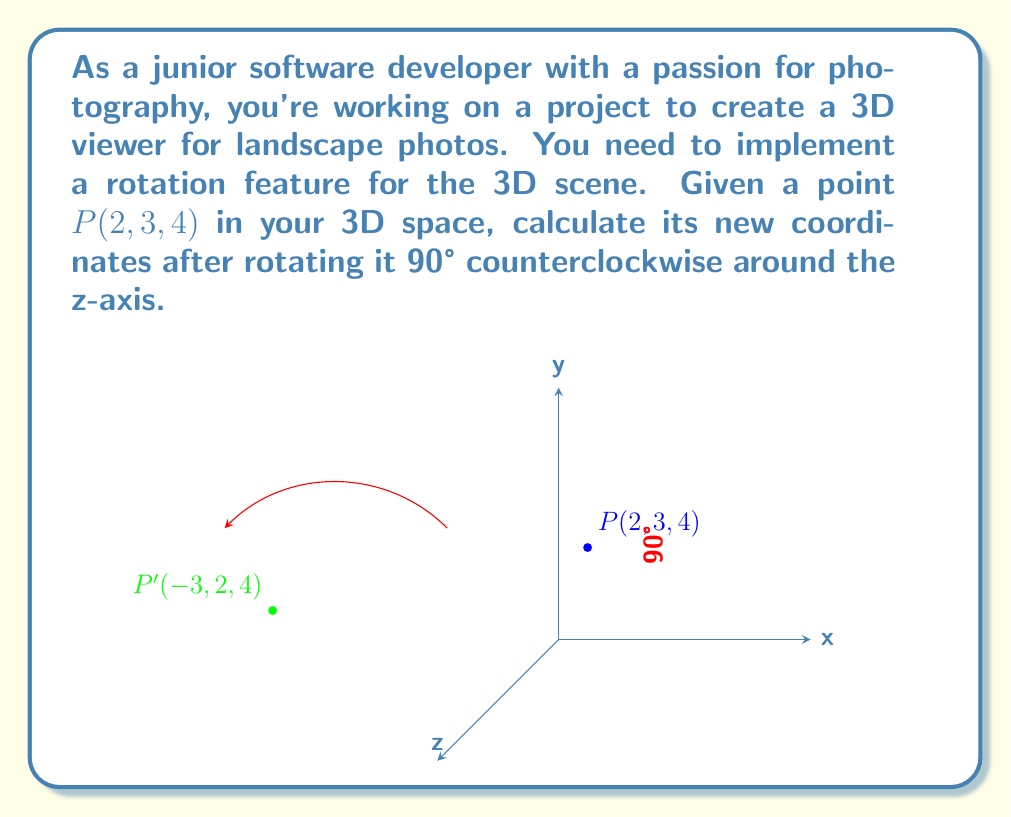Teach me how to tackle this problem. To solve this problem, we'll use the rotation matrix for a counterclockwise rotation around the z-axis:

$$R_z(\theta) = \begin{bmatrix}
\cos\theta & -\sin\theta & 0 \\
\sin\theta & \cos\theta & 0 \\
0 & 0 & 1
\end{bmatrix}$$

For a 90° rotation, $\theta = 90°$, so $\cos\theta = 0$ and $\sin\theta = 1$. The rotation matrix becomes:

$$R_z(90°) = \begin{bmatrix}
0 & -1 & 0 \\
1 & 0 & 0 \\
0 & 0 & 1
\end{bmatrix}$$

To find the new coordinates, we multiply this matrix by the original point vector:

$$\begin{bmatrix}
0 & -1 & 0 \\
1 & 0 & 0 \\
0 & 0 & 1
\end{bmatrix} \cdot \begin{bmatrix}
2 \\
3 \\
4
\end{bmatrix} = \begin{bmatrix}
(0 \cdot 2) + (-1 \cdot 3) + (0 \cdot 4) \\
(1 \cdot 2) + (0 \cdot 3) + (0 \cdot 4) \\
(0 \cdot 2) + (0 \cdot 3) + (1 \cdot 4)
\end{bmatrix} = \begin{bmatrix}
-3 \\
2 \\
4
\end{bmatrix}$$

Therefore, the new coordinates of point $P$ after rotation are $(-3, 2, 4)$.
Answer: $(-3, 2, 4)$ 